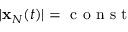<formula> <loc_0><loc_0><loc_500><loc_500>| { x } _ { N } ( t ) | = c o n s t</formula> 